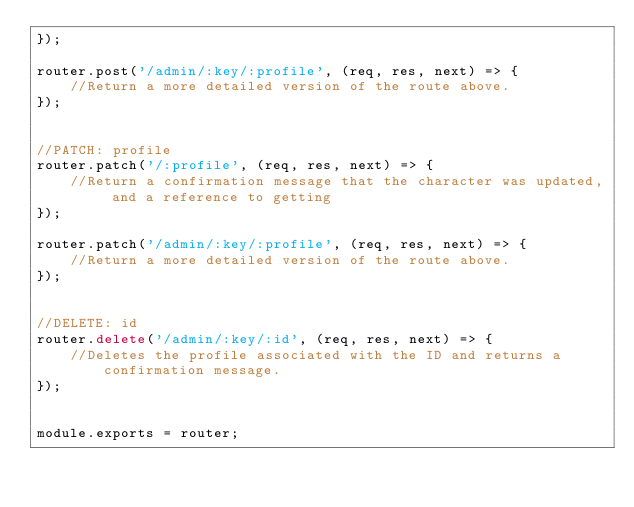<code> <loc_0><loc_0><loc_500><loc_500><_JavaScript_>});

router.post('/admin/:key/:profile', (req, res, next) => {
    //Return a more detailed version of the route above.
});


//PATCH: profile
router.patch('/:profile', (req, res, next) => {
    //Return a confirmation message that the character was updated, and a reference to getting 
});

router.patch('/admin/:key/:profile', (req, res, next) => {
    //Return a more detailed version of the route above.
});


//DELETE: id
router.delete('/admin/:key/:id', (req, res, next) => {
    //Deletes the profile associated with the ID and returns a confirmation message.
});


module.exports = router;</code> 